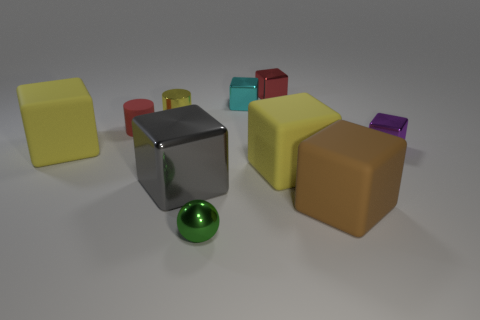Subtract 6 cubes. How many cubes are left? 1 Subtract all big matte blocks. How many blocks are left? 4 Subtract all cyan blocks. How many blocks are left? 6 Subtract 0 purple cylinders. How many objects are left? 10 Subtract all cylinders. How many objects are left? 8 Subtract all yellow spheres. Subtract all gray cubes. How many spheres are left? 1 Subtract all green blocks. How many yellow cylinders are left? 1 Subtract all tiny purple metal objects. Subtract all gray shiny blocks. How many objects are left? 8 Add 7 shiny spheres. How many shiny spheres are left? 8 Add 1 brown rubber objects. How many brown rubber objects exist? 2 